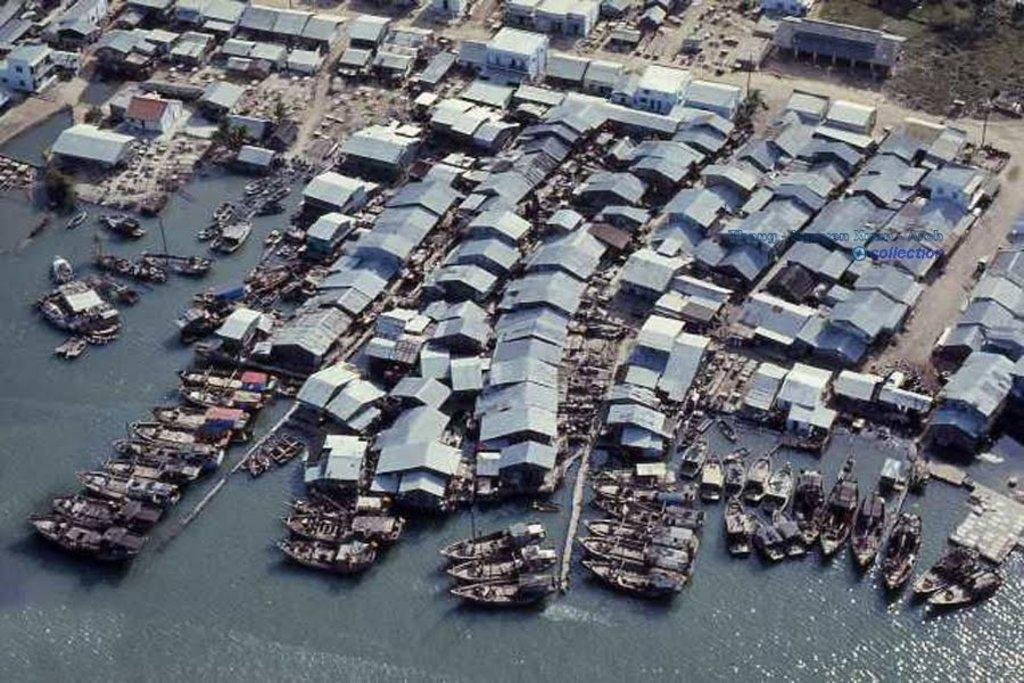What is on the water in the image? There are boats on the water in the image. What type of structures can be seen in the image? There are buildings in the image. Can you describe any architectural features visible in the image? There are roofs visible in the image. What type of instrument can be heard playing in the image? There is no instrument or sound present in the image, as it is a still image. 